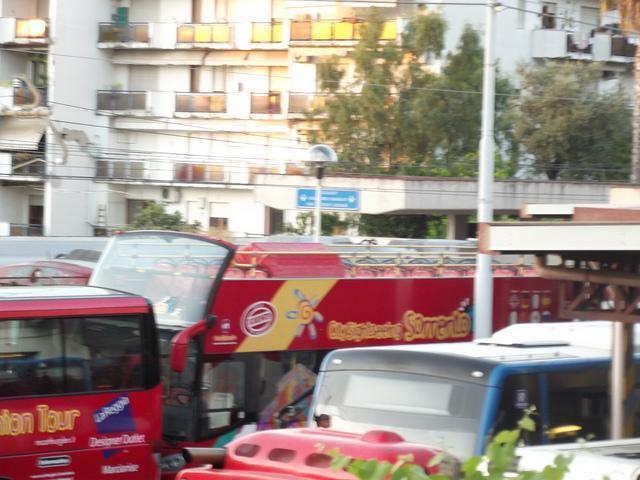What would someone be riding on top of the red bus for?
Answer the question by selecting the correct answer among the 4 following choices.
Options: Tours, sleeping, shooting, eating. Tours. 